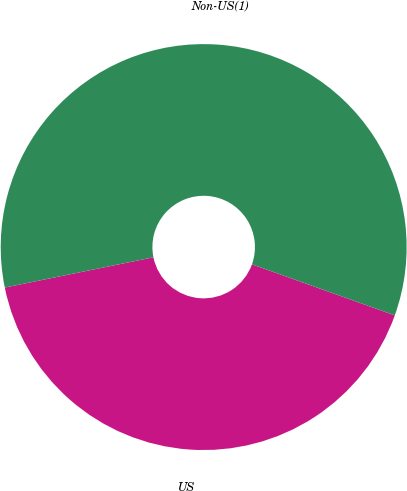<chart> <loc_0><loc_0><loc_500><loc_500><pie_chart><fcel>US<fcel>Non-US(1)<nl><fcel>41.34%<fcel>58.66%<nl></chart> 